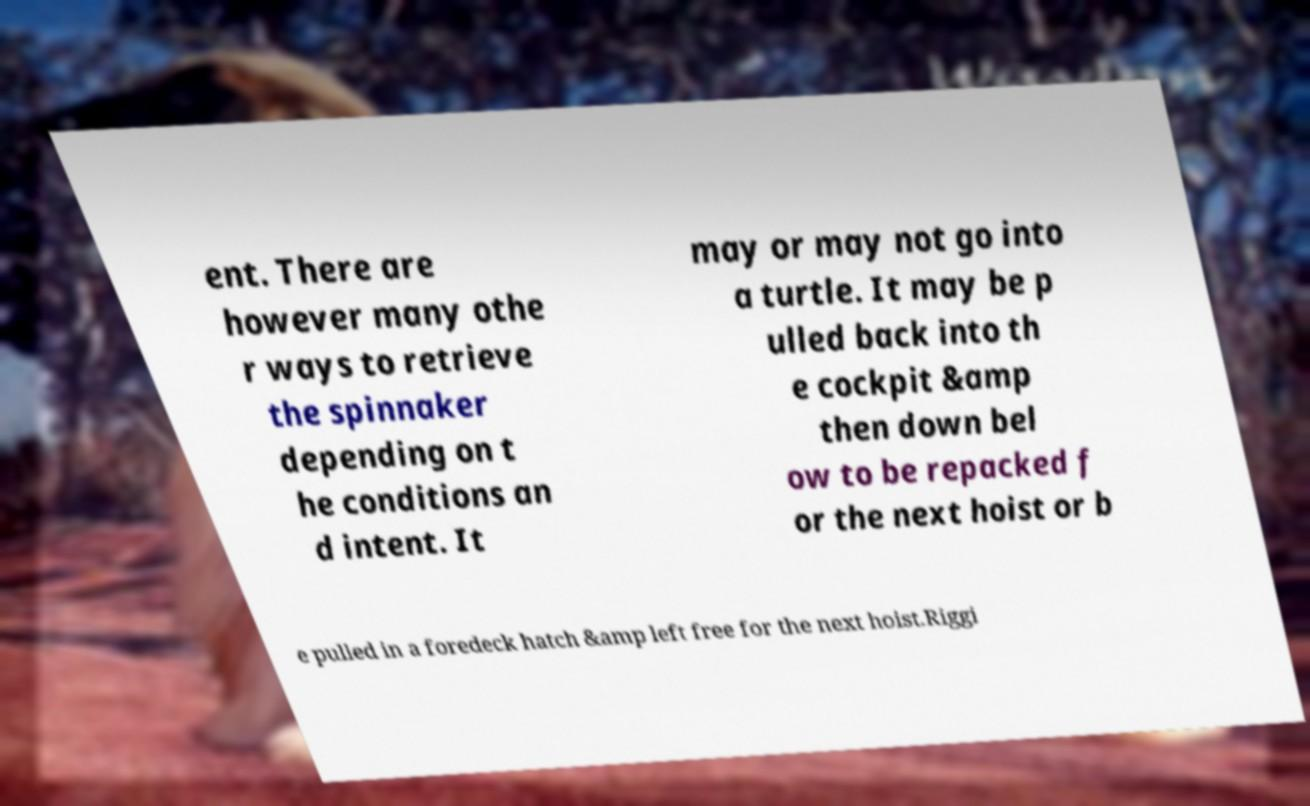What messages or text are displayed in this image? I need them in a readable, typed format. ent. There are however many othe r ways to retrieve the spinnaker depending on t he conditions an d intent. It may or may not go into a turtle. It may be p ulled back into th e cockpit &amp then down bel ow to be repacked f or the next hoist or b e pulled in a foredeck hatch &amp left free for the next hoist.Riggi 